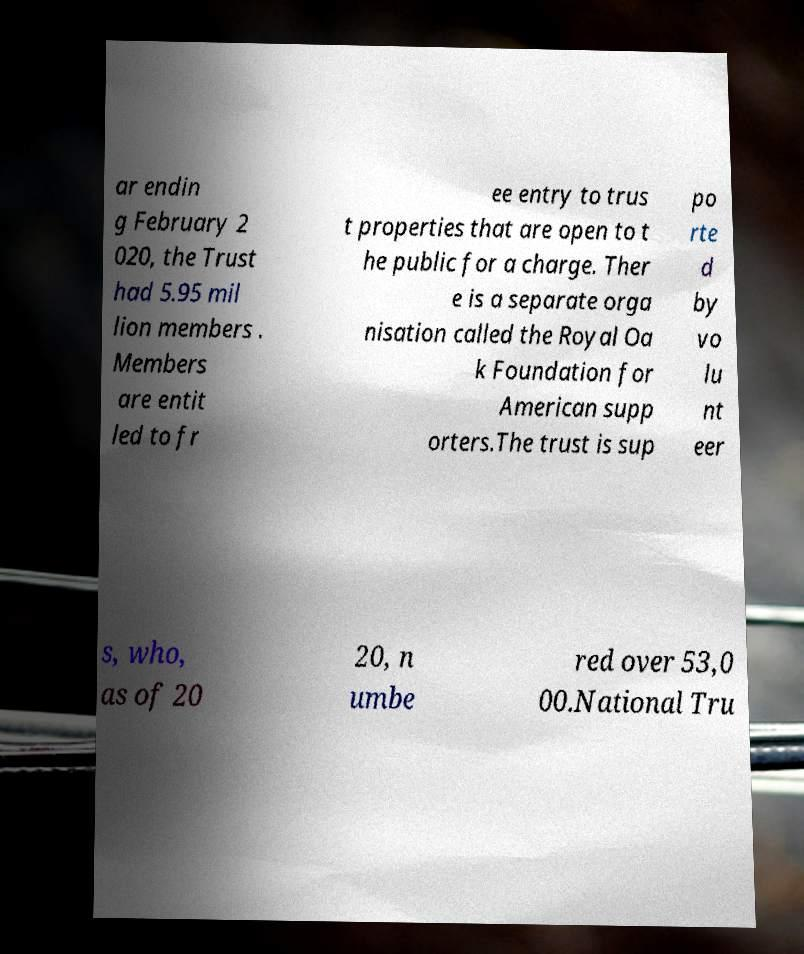Could you extract and type out the text from this image? ar endin g February 2 020, the Trust had 5.95 mil lion members . Members are entit led to fr ee entry to trus t properties that are open to t he public for a charge. Ther e is a separate orga nisation called the Royal Oa k Foundation for American supp orters.The trust is sup po rte d by vo lu nt eer s, who, as of 20 20, n umbe red over 53,0 00.National Tru 